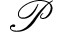<formula> <loc_0><loc_0><loc_500><loc_500>\mathcal { P }</formula> 